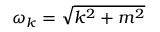Convert formula to latex. <formula><loc_0><loc_0><loc_500><loc_500>\omega _ { k } = { \sqrt { k ^ { 2 } + m ^ { 2 } } }</formula> 